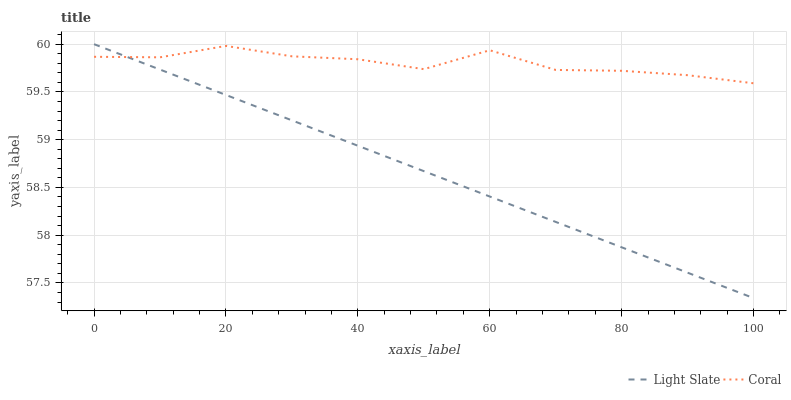Does Light Slate have the minimum area under the curve?
Answer yes or no. Yes. Does Coral have the maximum area under the curve?
Answer yes or no. Yes. Does Coral have the minimum area under the curve?
Answer yes or no. No. Is Light Slate the smoothest?
Answer yes or no. Yes. Is Coral the roughest?
Answer yes or no. Yes. Is Coral the smoothest?
Answer yes or no. No. Does Light Slate have the lowest value?
Answer yes or no. Yes. Does Coral have the lowest value?
Answer yes or no. No. Does Light Slate have the highest value?
Answer yes or no. Yes. Does Coral have the highest value?
Answer yes or no. No. Does Coral intersect Light Slate?
Answer yes or no. Yes. Is Coral less than Light Slate?
Answer yes or no. No. Is Coral greater than Light Slate?
Answer yes or no. No. 